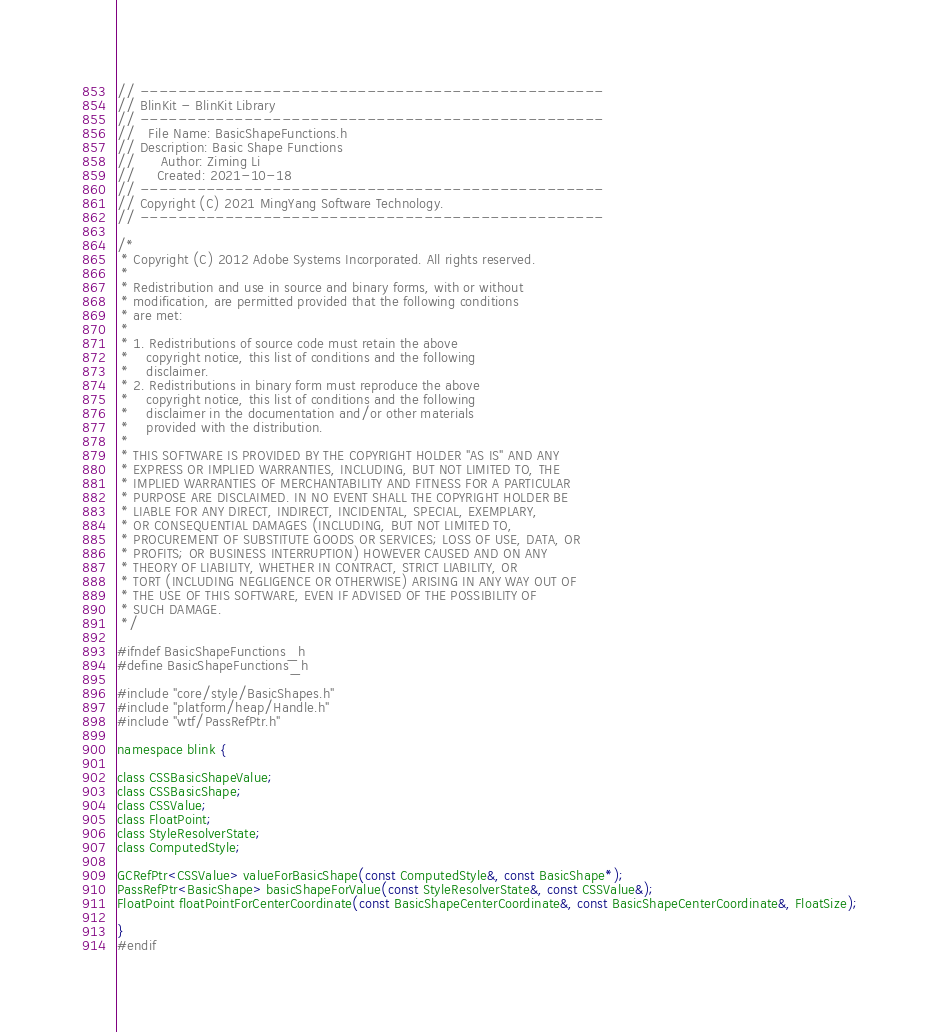<code> <loc_0><loc_0><loc_500><loc_500><_C_>// -------------------------------------------------
// BlinKit - BlinKit Library
// -------------------------------------------------
//   File Name: BasicShapeFunctions.h
// Description: Basic Shape Functions
//      Author: Ziming Li
//     Created: 2021-10-18
// -------------------------------------------------
// Copyright (C) 2021 MingYang Software Technology.
// -------------------------------------------------

/*
 * Copyright (C) 2012 Adobe Systems Incorporated. All rights reserved.
 *
 * Redistribution and use in source and binary forms, with or without
 * modification, are permitted provided that the following conditions
 * are met:
 *
 * 1. Redistributions of source code must retain the above
 *    copyright notice, this list of conditions and the following
 *    disclaimer.
 * 2. Redistributions in binary form must reproduce the above
 *    copyright notice, this list of conditions and the following
 *    disclaimer in the documentation and/or other materials
 *    provided with the distribution.
 *
 * THIS SOFTWARE IS PROVIDED BY THE COPYRIGHT HOLDER "AS IS" AND ANY
 * EXPRESS OR IMPLIED WARRANTIES, INCLUDING, BUT NOT LIMITED TO, THE
 * IMPLIED WARRANTIES OF MERCHANTABILITY AND FITNESS FOR A PARTICULAR
 * PURPOSE ARE DISCLAIMED. IN NO EVENT SHALL THE COPYRIGHT HOLDER BE
 * LIABLE FOR ANY DIRECT, INDIRECT, INCIDENTAL, SPECIAL, EXEMPLARY,
 * OR CONSEQUENTIAL DAMAGES (INCLUDING, BUT NOT LIMITED TO,
 * PROCUREMENT OF SUBSTITUTE GOODS OR SERVICES; LOSS OF USE, DATA, OR
 * PROFITS; OR BUSINESS INTERRUPTION) HOWEVER CAUSED AND ON ANY
 * THEORY OF LIABILITY, WHETHER IN CONTRACT, STRICT LIABILITY, OR
 * TORT (INCLUDING NEGLIGENCE OR OTHERWISE) ARISING IN ANY WAY OUT OF
 * THE USE OF THIS SOFTWARE, EVEN IF ADVISED OF THE POSSIBILITY OF
 * SUCH DAMAGE.
 */

#ifndef BasicShapeFunctions_h
#define BasicShapeFunctions_h

#include "core/style/BasicShapes.h"
#include "platform/heap/Handle.h"
#include "wtf/PassRefPtr.h"

namespace blink {

class CSSBasicShapeValue;
class CSSBasicShape;
class CSSValue;
class FloatPoint;
class StyleResolverState;
class ComputedStyle;

GCRefPtr<CSSValue> valueForBasicShape(const ComputedStyle&, const BasicShape*);
PassRefPtr<BasicShape> basicShapeForValue(const StyleResolverState&, const CSSValue&);
FloatPoint floatPointForCenterCoordinate(const BasicShapeCenterCoordinate&, const BasicShapeCenterCoordinate&, FloatSize);

}
#endif
</code> 